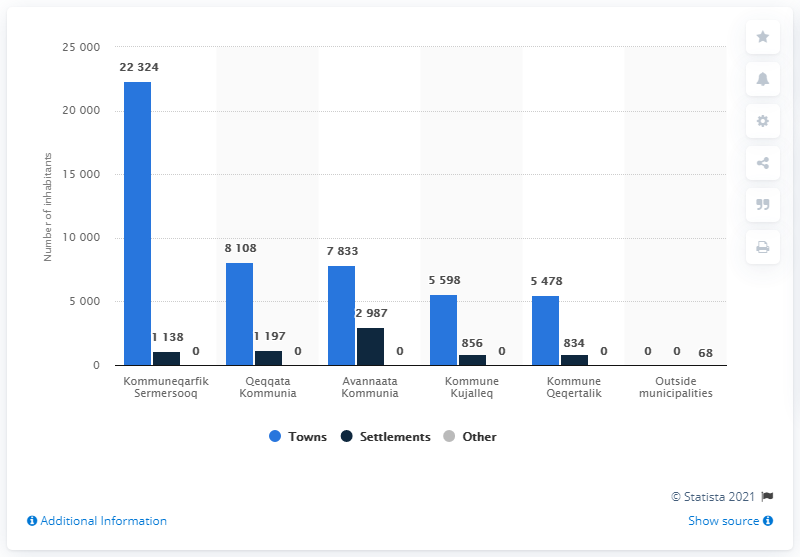Specify some key components in this picture. The smallest municipality in Greenland is Kommune Qeqertalik. In 2020, there were approximately 22,324 people living in the towns within the Kommuneqarfik Sermersooq municipality. 